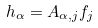<formula> <loc_0><loc_0><loc_500><loc_500>h _ { \alpha } = A _ { \alpha , j } f _ { j }</formula> 